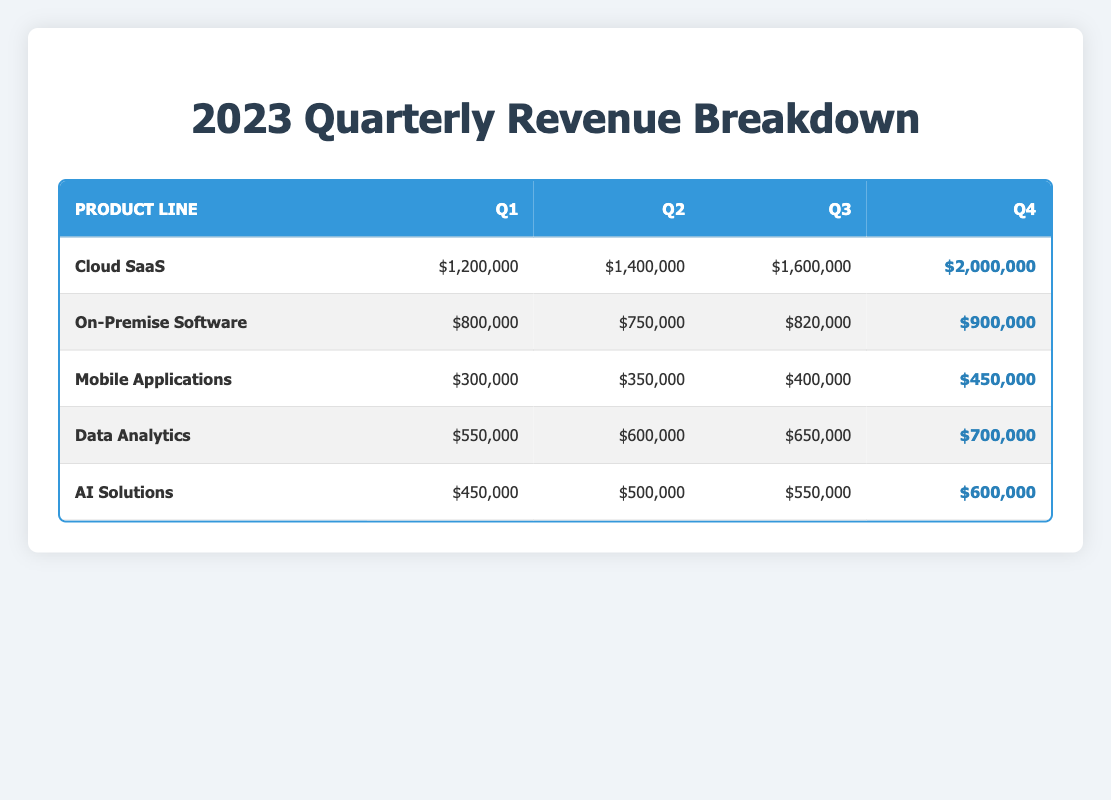What was the total revenue from Cloud SaaS in Q2? According to the table, the revenue from Cloud SaaS in Q2 is $1,400,000. Therefore, the answer is directly derived from this data point.
Answer: $1,400,000 Which product line had the highest revenue in Q4? By comparing the revenue figures in Q4 for each product line, Cloud SaaS has $2,000,000, which is higher than all other product lines listed.
Answer: Cloud SaaS What is the sum of revenues for Mobile Applications across all quarters? The revenues for Mobile Applications are: Q1 = $300,000, Q2 = $350,000, Q3 = $400,000, and Q4 = $450,000. The total is calculated as: 300,000 + 350,000 + 400,000 + 450,000 = $1,500,000.
Answer: $1,500,000 Did AI Solutions generate more revenue in Q3 than Data Analytics in Q2? AI Solutions revenue in Q3 is $550,000, while Data Analytics revenue in Q2 is $600,000. Since $550,000 is not greater than $600,000, the answer is no.
Answer: No What is the difference in revenue between On-Premise Software in Q2 and Q4? The revenue for On-Premise Software in Q2 is $750,000, and in Q4 it is $900,000. The difference is calculated by subtracting Q2 from Q4: $900,000 - $750,000 = $150,000.
Answer: $150,000 What is the average revenue for Data Analytics across all four quarters? The revenues for Data Analytics are: Q1 = $550,000, Q2 = $600,000, Q3 = $650,000, and Q4 = $700,000. The sum is $550,000 + $600,000 + $650,000 + $700,000 = $2,500,000. The average is calculated as $2,500,000 / 4 = $625,000.
Answer: $625,000 Which product line experienced the largest increase in revenue from Q1 to Q4? The increases in revenue from Q1 to Q4 for each product line are as follows: Cloud SaaS increased by $800,000, On-Premise Software by $100,000, Mobile Applications by $150,000, Data Analytics by $150,000, and AI Solutions by $150,000. The largest increase is for Cloud SaaS at $800,000.
Answer: Cloud SaaS Is the total revenue for On-Premise Software higher than that for Mobile Applications across all quarters? The total for On-Premise Software is $800,000 (Q1) + $750,000 (Q2) + $820,000 (Q3) + $900,000 (Q4) = $3,270,000. The total for Mobile Applications is $300,000 + $350,000 + $400,000 + $450,000 = $1,500,000. Since $3,270,000 is greater than $1,500,000, the answer is yes.
Answer: Yes In which quarter did AI Solutions have the least revenue? Reviewing the table, AI Solutions had revenues of $450,000 (Q1), $500,000 (Q2), $550,000 (Q3), and $600,000 (Q4). The least revenue is in Q1, where it earned $450,000.
Answer: Q1 What percentage of total revenue in Q3 did Cloud SaaS represent? The total revenue across all product lines in Q3 is calculated as $1,600,000 (Cloud SaaS) + $820,000 (On-Premise Software) + $400,000 (Mobile Applications) + $650,000 (Data Analytics) + $550,000 (AI Solutions) = $4,020,000. The percentage from Cloud SaaS is ($1,600,000 / $4,020,000) * 100 = approximately 39.84%.
Answer: Approximately 39.84% 